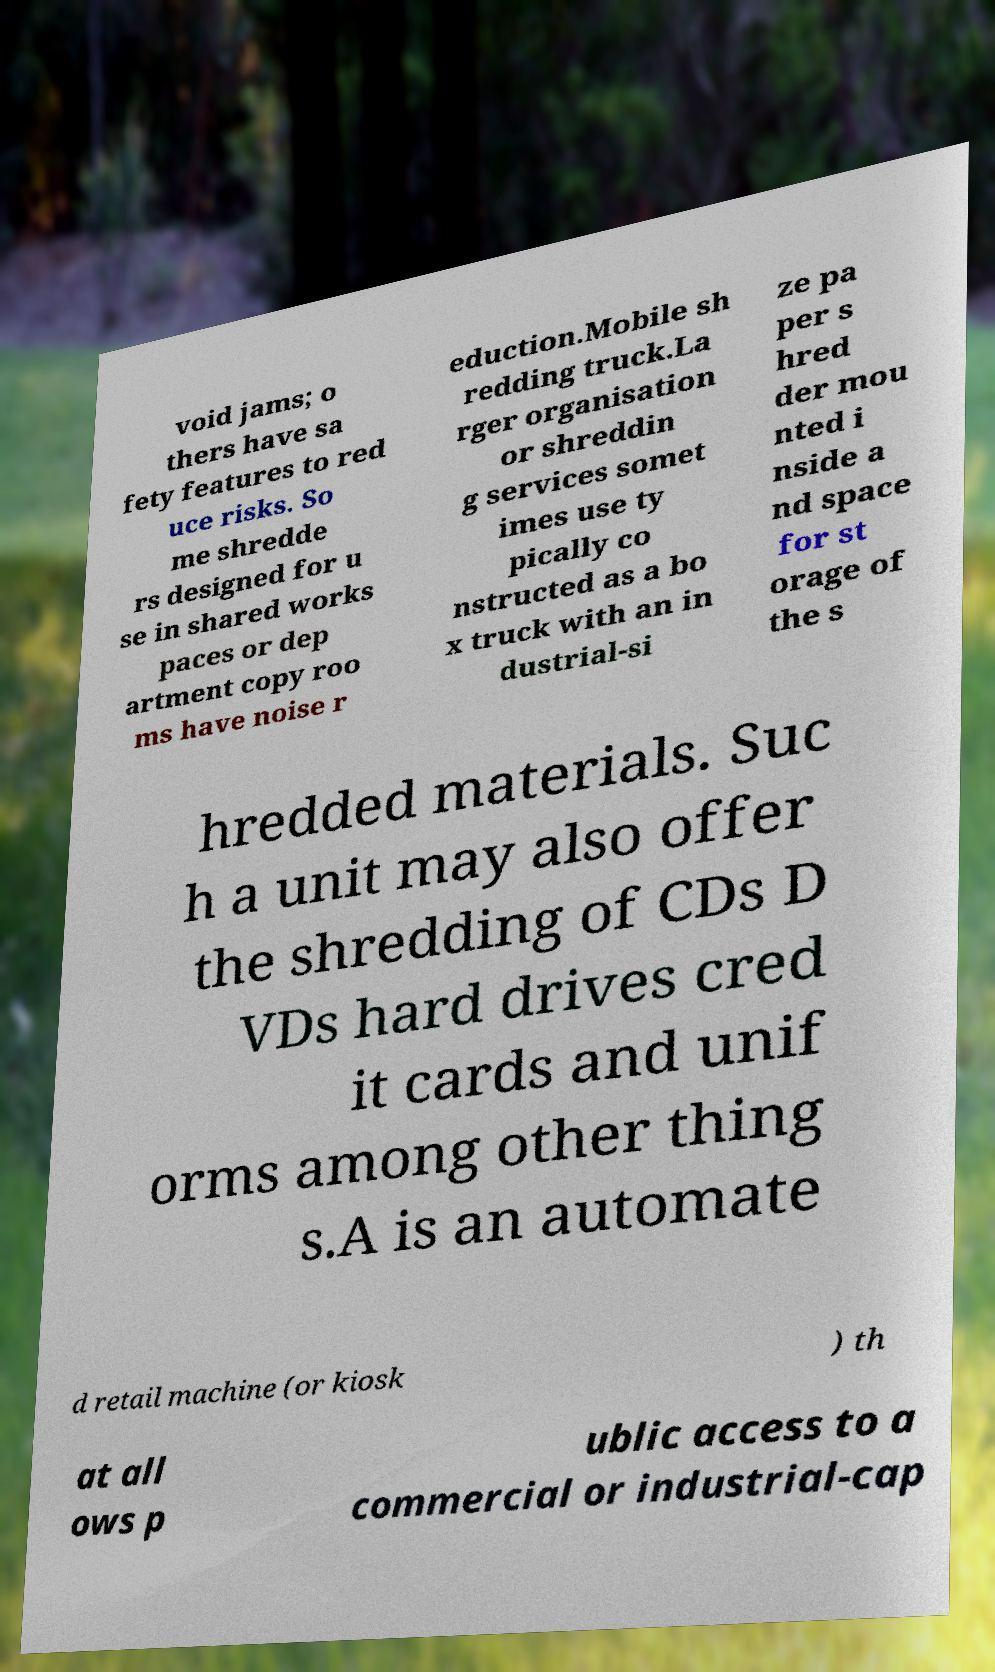I need the written content from this picture converted into text. Can you do that? void jams; o thers have sa fety features to red uce risks. So me shredde rs designed for u se in shared works paces or dep artment copy roo ms have noise r eduction.Mobile sh redding truck.La rger organisation or shreddin g services somet imes use ty pically co nstructed as a bo x truck with an in dustrial-si ze pa per s hred der mou nted i nside a nd space for st orage of the s hredded materials. Suc h a unit may also offer the shredding of CDs D VDs hard drives cred it cards and unif orms among other thing s.A is an automate d retail machine (or kiosk ) th at all ows p ublic access to a commercial or industrial-cap 